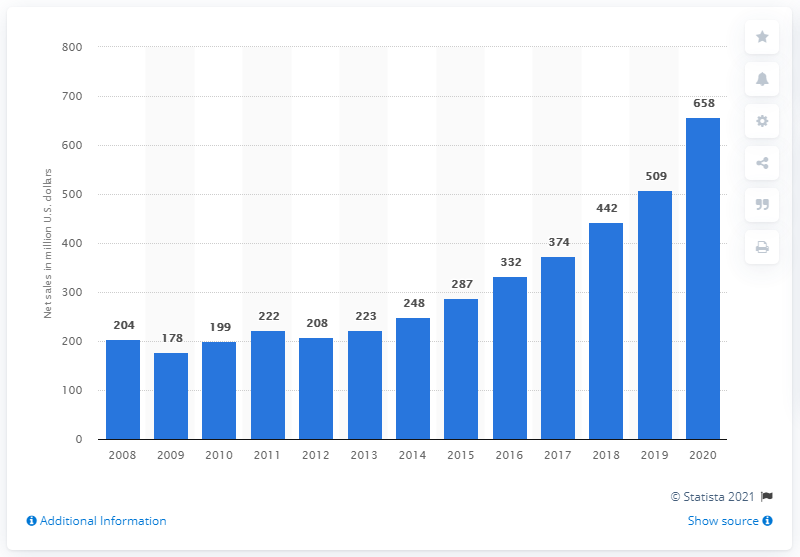Identify some key points in this picture. Garmin's marine segment sold 208 dollars in 2012. Garmin generated approximately $658 million in revenue in the United States in 2020. In 2012, Garmin's marine segment experienced a significant increase in sales, amounting to 208 million U.S. dollars. 